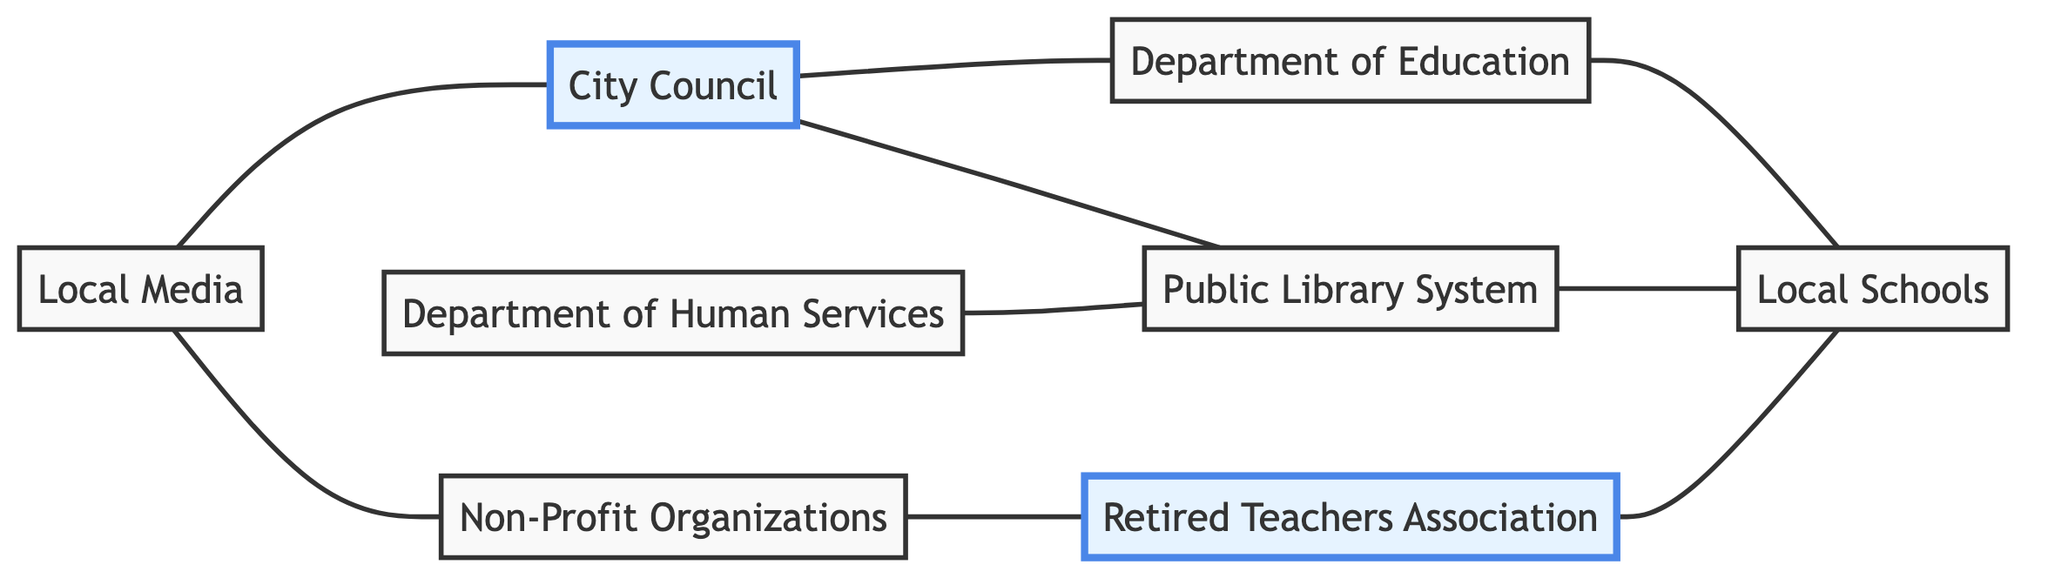What is the total number of nodes in the diagram? The diagram contains eight distinct entities labeled as nodes. They include the Department of Education, Public Library System, Local Schools, Non-Profit Organizations, Retired Teachers Association, Department of Human Services, City Council, and Local Media. Thus, the total count is 8.
Answer: 8 Which department collaborates with Local Schools on literacy outreach programs? The edge between the Public Library System and Local Schools indicates a collaboration specifically on literacy outreach programs. Therefore, the Public Library System is the department in question.
Answer: Public Library System How many edges connect to the City Council? By reviewing the connections originating from the City Council, there are three distinct edges leading to the Department of Education, Public Library System, and Local Media. Thus, the total number of edges connected to the City Council is 3.
Answer: 3 What type of organizations engages retired teachers for volunteering? The edge between Non-Profit Organizations and Retired Teachers Association notes that it is the Non-Profit Organizations that engage, indicating their role in recruiting retired teachers for literacy projects.
Answer: Non-Profit Organizations Which node provides policy and curriculum guidelines? The relationship between the Department of Education and Local Schools, as indicated through the edge, shows that the Department of Education provides the relevant policy and curriculum guidelines.
Answer: Department of Education How many organizations directly interact with the Public Library System? The Public Library System has connections with Local Schools, Department of Human Services, and City Council, thus indicating it interacts directly with three organizations.
Answer: 3 What role does Local Media play in the context of the City Council? The connection shows that Local Media is responsible for promoting public literacy events associated with the City Council, indicating their supportive role in amplifying the council's initiatives.
Answer: Promotes public literacy events Which node does the Retired Teachers Association mentor? The edge between Retired Teachers Association and Local Schools indicates that the retired teachers specifically engage in mentoring students at Local Schools.
Answer: Local Schools What is the purpose of the Department of Human Services in this diagram? This department is connected to the Public Library System and depicts its partnership role, specifically aimed at supporting disadvantaged families through adult literacy programs, showcasing its community-focused initiative.
Answer: Supports disadvantaged families 